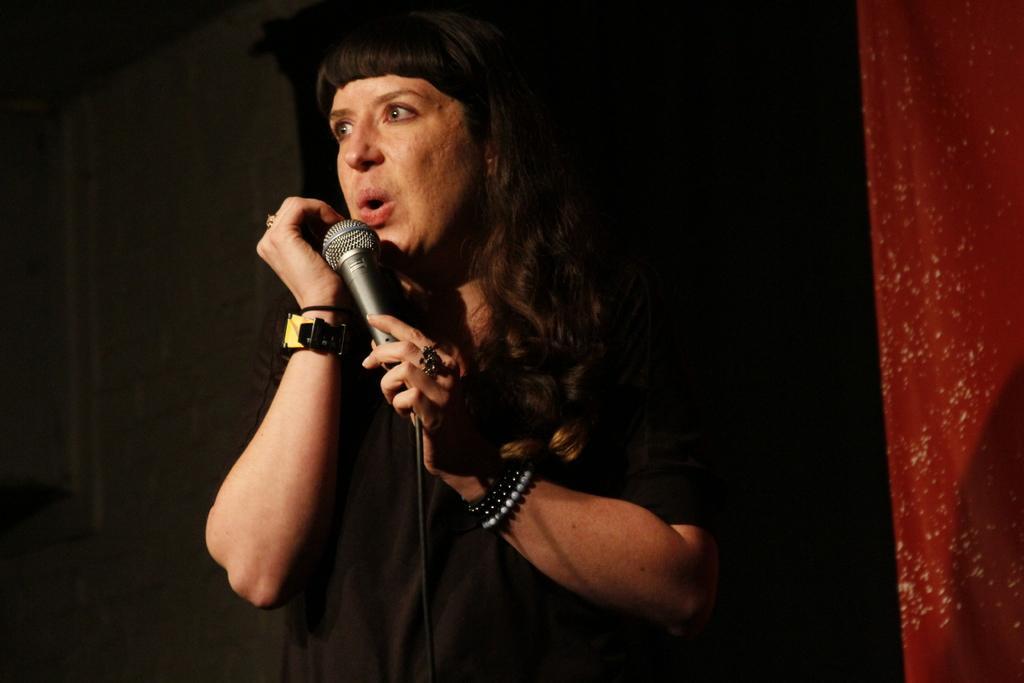How would you summarize this image in a sentence or two? This is the picture of a person who is holding the mic and we can see some bands and a watch to the hand. 